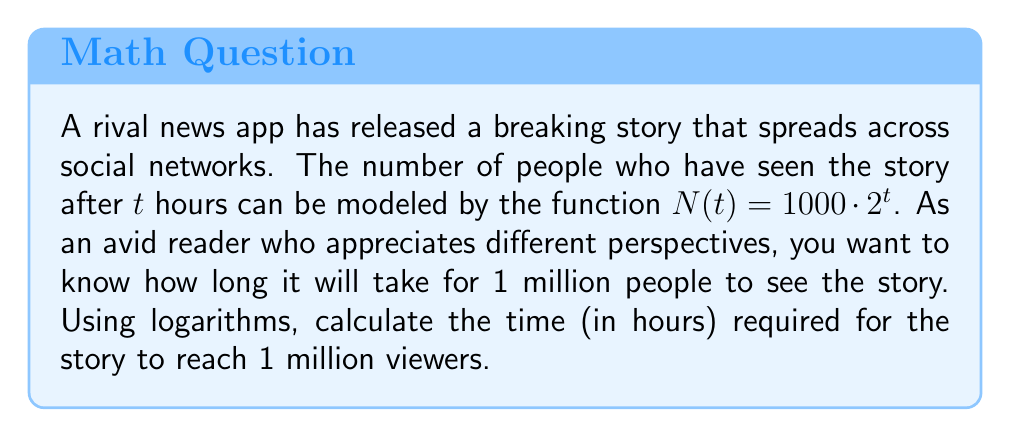Could you help me with this problem? Let's approach this step-by-step:

1) We're given the function $N(t) = 1000 \cdot 2^t$, where $N$ is the number of people who have seen the story and $t$ is the time in hours.

2) We want to find $t$ when $N(t) = 1,000,000$ (1 million viewers).

3) Let's set up the equation:
   $1,000,000 = 1000 \cdot 2^t$

4) Divide both sides by 1000:
   $1,000 = 2^t$

5) Now we can apply logarithms to both sides. Since the base is 2, we'll use $\log_2$:
   $\log_2(1,000) = \log_2(2^t)$

6) Using the logarithm property $\log_a(a^x) = x$, we get:
   $\log_2(1,000) = t$

7) We can calculate $\log_2(1,000)$ using the change of base formula:
   $t = \frac{\log(1,000)}{\log(2)} \approx 9.97$ hours

Therefore, it will take approximately 9.97 hours for the story to reach 1 million viewers.
Answer: $9.97$ hours 